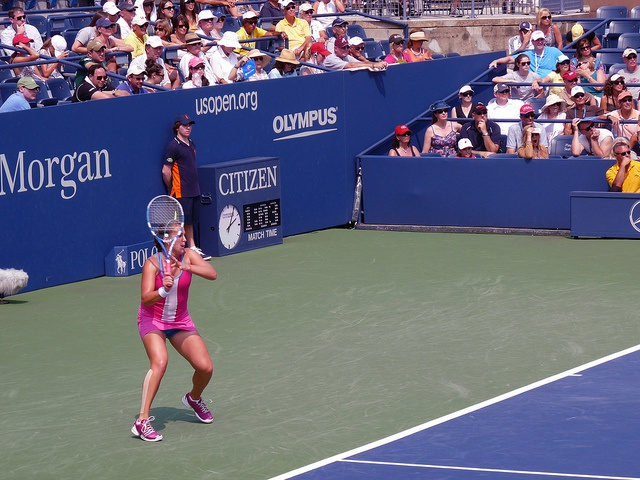Describe the objects in this image and their specific colors. I can see people in black, navy, lightgray, and blue tones, people in black, lightpink, maroon, brown, and salmon tones, tennis racket in black, gray, and purple tones, people in black, lightpink, navy, and violet tones, and people in black, navy, brown, and lightpink tones in this image. 